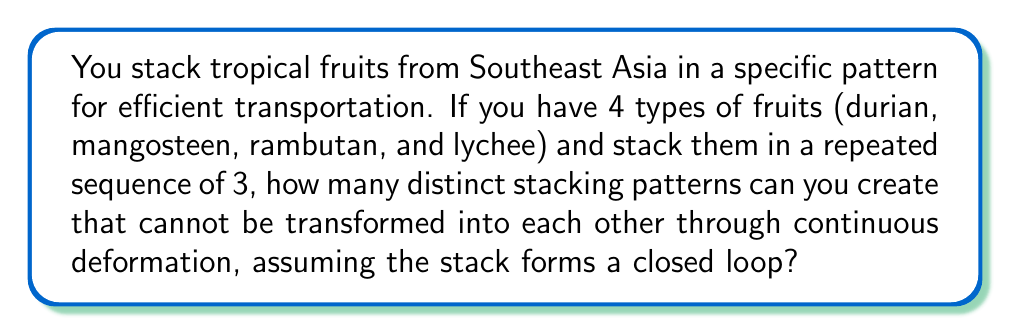Solve this math problem. To solve this problem, we need to use concepts from braid theory and group theory:

1. First, we recognize that this stacking pattern forms a 4-strand braid with 3 crossings, as we have 4 types of fruits and a sequence of 3.

2. In braid theory, the number of distinct patterns that cannot be transformed into each other through continuous deformation is given by the order of the braid group $B_n$ divided by $n!$, where $n$ is the number of strands.

3. The order of the braid group $B_4$ with 3 crossings is given by the formula:

   $$|B_4| = 4! \cdot 4^3 = 24 \cdot 64 = 1536$$

4. To find the number of distinct patterns, we divide this by 4!:

   $$\frac{|B_4|}{4!} = \frac{1536}{24} = 64$$

5. Therefore, there are 64 distinct stacking patterns that cannot be transformed into each other through continuous deformation.

This result represents the number of different ways you can stack your four types of fruits in a repeated sequence of three that will result in fundamentally different arrangements, considering the stack as a closed loop.
Answer: 64 